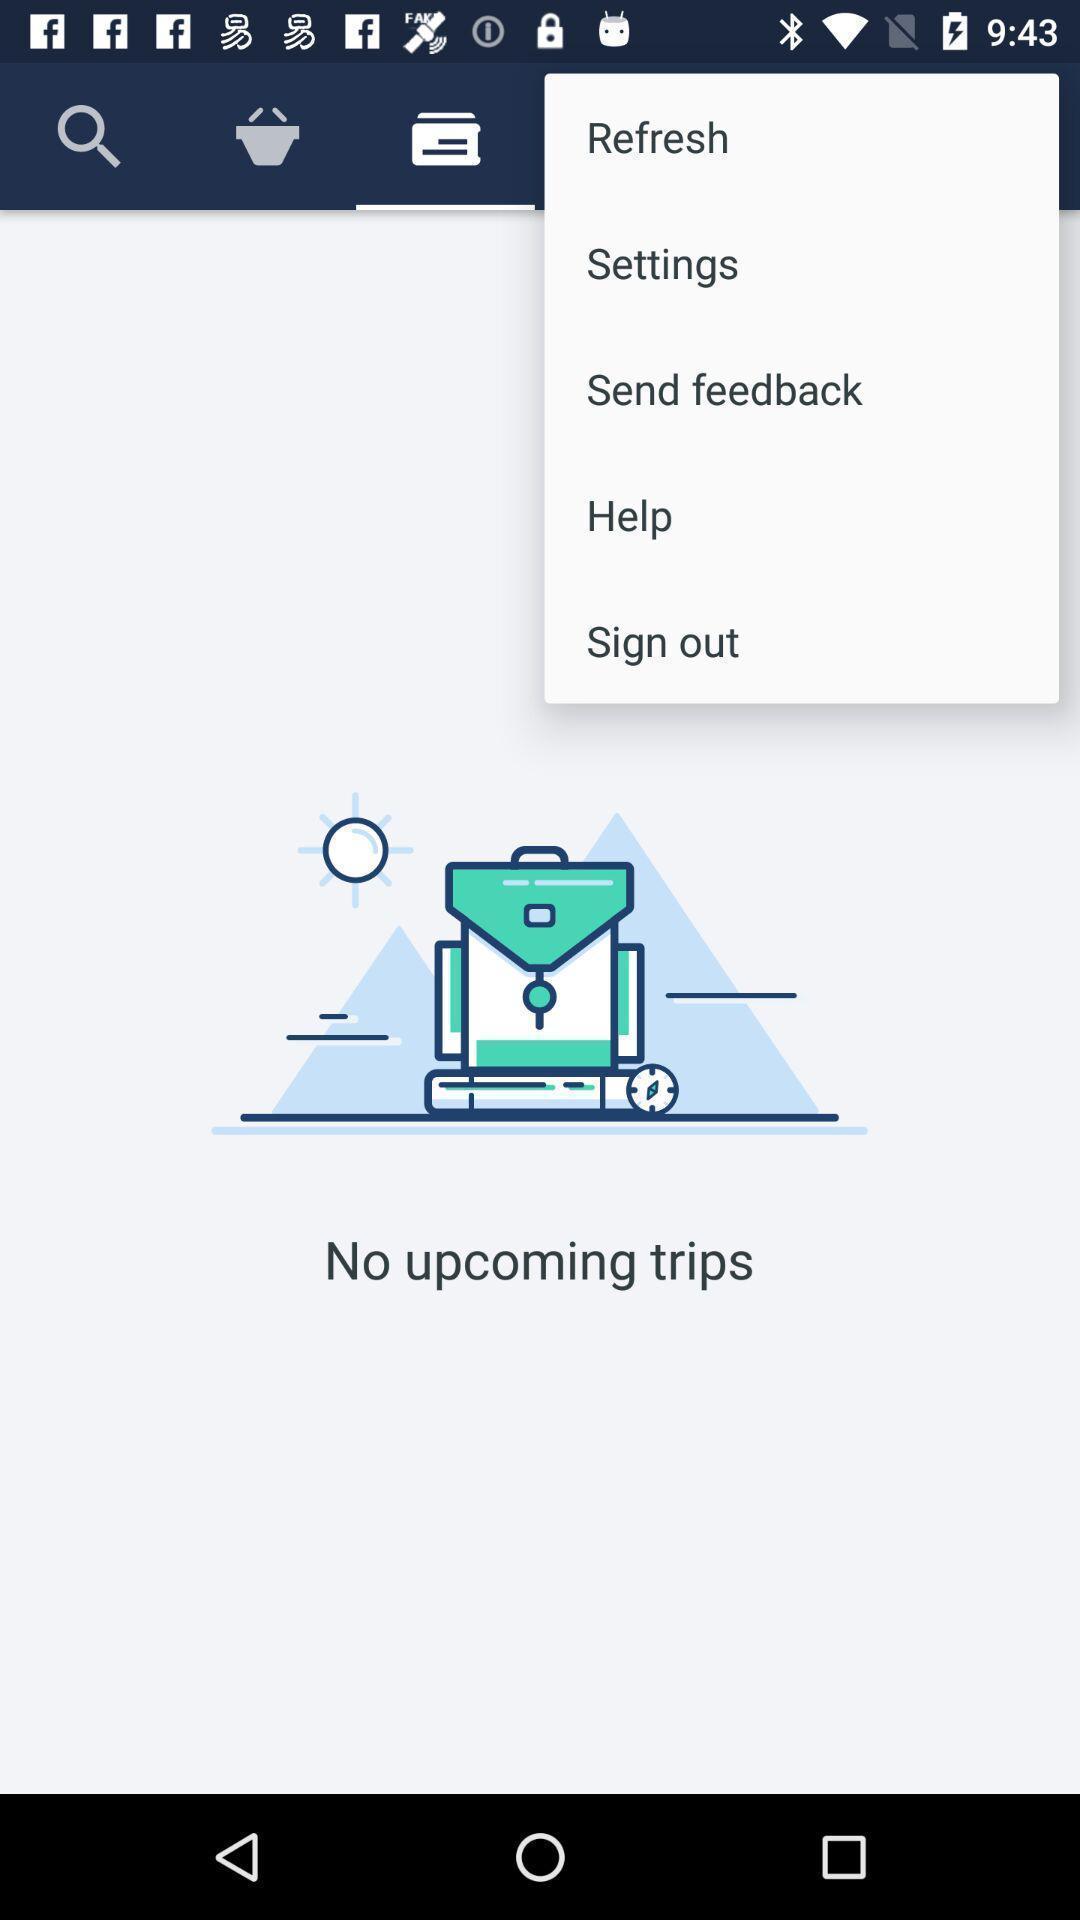Give me a narrative description of this picture. Popup displaying options in the app. 